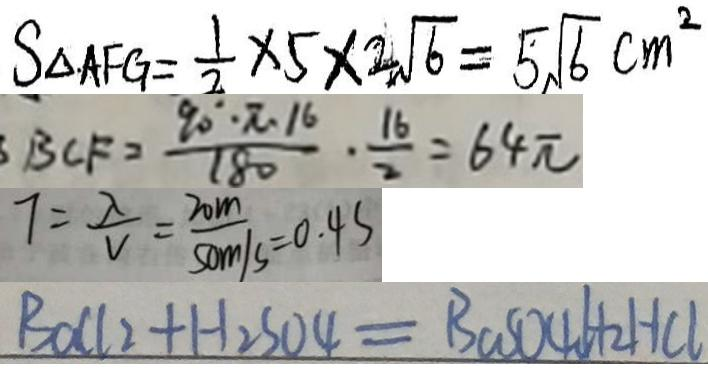Convert formula to latex. <formula><loc_0><loc_0><loc_500><loc_500>S _ { \Delta A F G } = \frac { 1 } { 2 } \times 5 \times 2 \sqrt { 6 } = 5 \sqrt { 6 } c m ^ { 2 } 
 B C F = \frac { 9 0 ^ { \circ } \cdot \pi \cdot 1 6 } { 1 8 0 } \cdot \frac { 1 6 } { 2 } = 6 4 \pi 
 7 = \frac { \lambda } { V } = \frac { 2 0 m } { 5 0 m / s } = 0 . 4 s 
 B a C l _ { 2 } + H _ { 2 } S O 4 = B \cos O 4 6 H + 2 H C l</formula> 